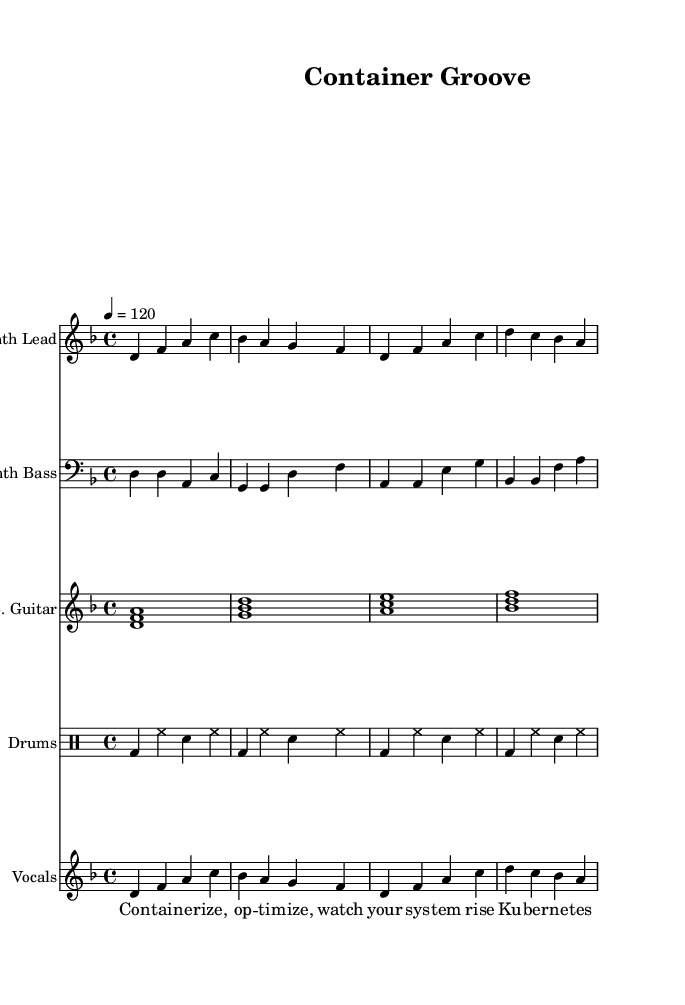What is the key signature of this music? The key signature is D minor, as indicated by the one flat (B flat) in the key signature section of the music sheet.
Answer: D minor What is the time signature of this music? The time signature is 4/4, which indicates four beats per measure, and is visible at the beginning of the score.
Answer: 4/4 What is the tempo marking for this piece? The tempo marking is 120 beats per minute, as specified in the tempo section of the music, indicating the speed at which the piece should be played.
Answer: 120 How many measures does the synthesizer lead part contain? The synthesizer lead part contains four measures, which can be counted by observing the groupings of notes and the bar lines in that section.
Answer: Four Which instruments are present in this score? The instruments in this score are Synth Lead, Synth Bass, Electric Guitar, and Drums, which can be identified by their respective staff labels at the beginning of each line.
Answer: Synth Lead, Synth Bass, Electric Guitar, Drums What is the lyrical theme of this song? The lyrical theme centers around containerization and Kubernetes, as evidenced by the lyrics discussing terms like "containerize," "optimize," and "Kubernetes orchestrates."
Answer: Containerization and Kubernetes Which instrument plays a rhythmic accompaniment in this arrangement? The drums are responsible for providing rhythmic accompaniment, which can be determined by identifying the drum pattern section within the score designated specifically for drums.
Answer: Drums 